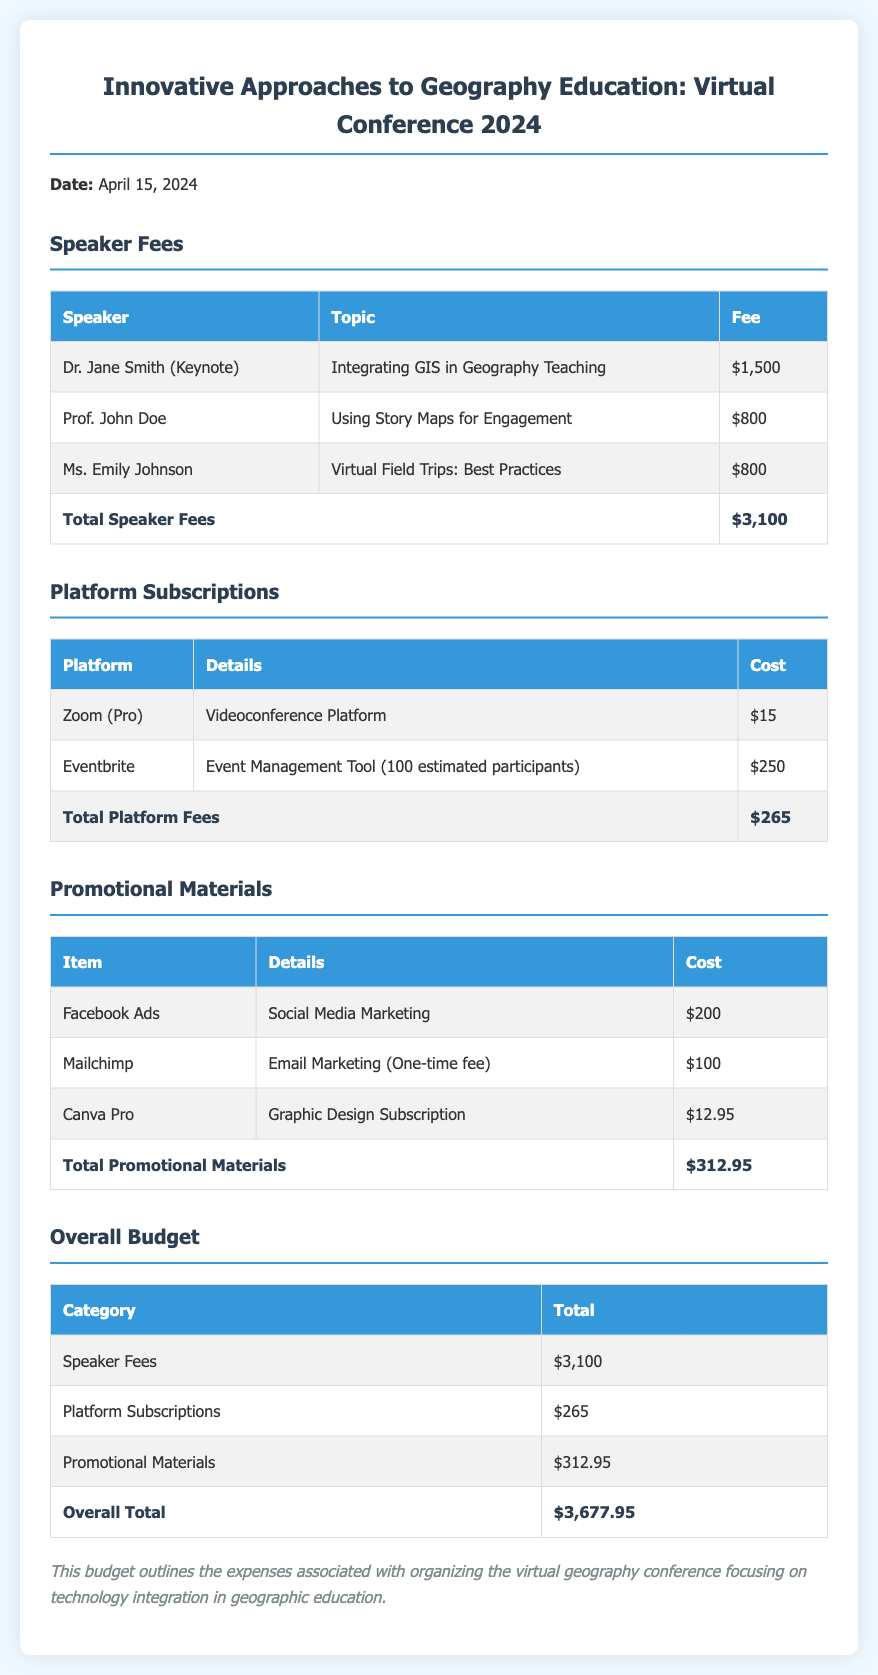What is the date of the virtual geography conference? The date of the conference is explicitly mentioned in the document as April 15, 2024.
Answer: April 15, 2024 Who is the keynote speaker? The document lists Dr. Jane Smith as the keynote speaker for the conference.
Answer: Dr. Jane Smith What is the total speaker fee? The total speaker fee is summarized at the bottom of the speaker fees section in the document.
Answer: $3,100 How much does the Mailchimp service cost? The cost of Mailchimp is provided in the promotional materials section.
Answer: $100 What is the total cost for platform subscriptions? The document provides a total for platform subscriptions, which includes individual costs of services mentioned.
Answer: $265 Which platform is used for videoconferencing? The document specifies Zoom as the videoconference platform for the event.
Answer: Zoom What is the overall budget for the conference? The overall budget is calculated and presented at the end of the budget tables in the document.
Answer: $3,677.95 How many estimated participants are considered for Eventbrite? The document notes that there are 100 estimated participants for Eventbrite.
Answer: 100 What type of conference is being organized? The title of the document makes clear that it is a virtual geography conference focusing on technology integration in geography education.
Answer: Virtual geography conference 